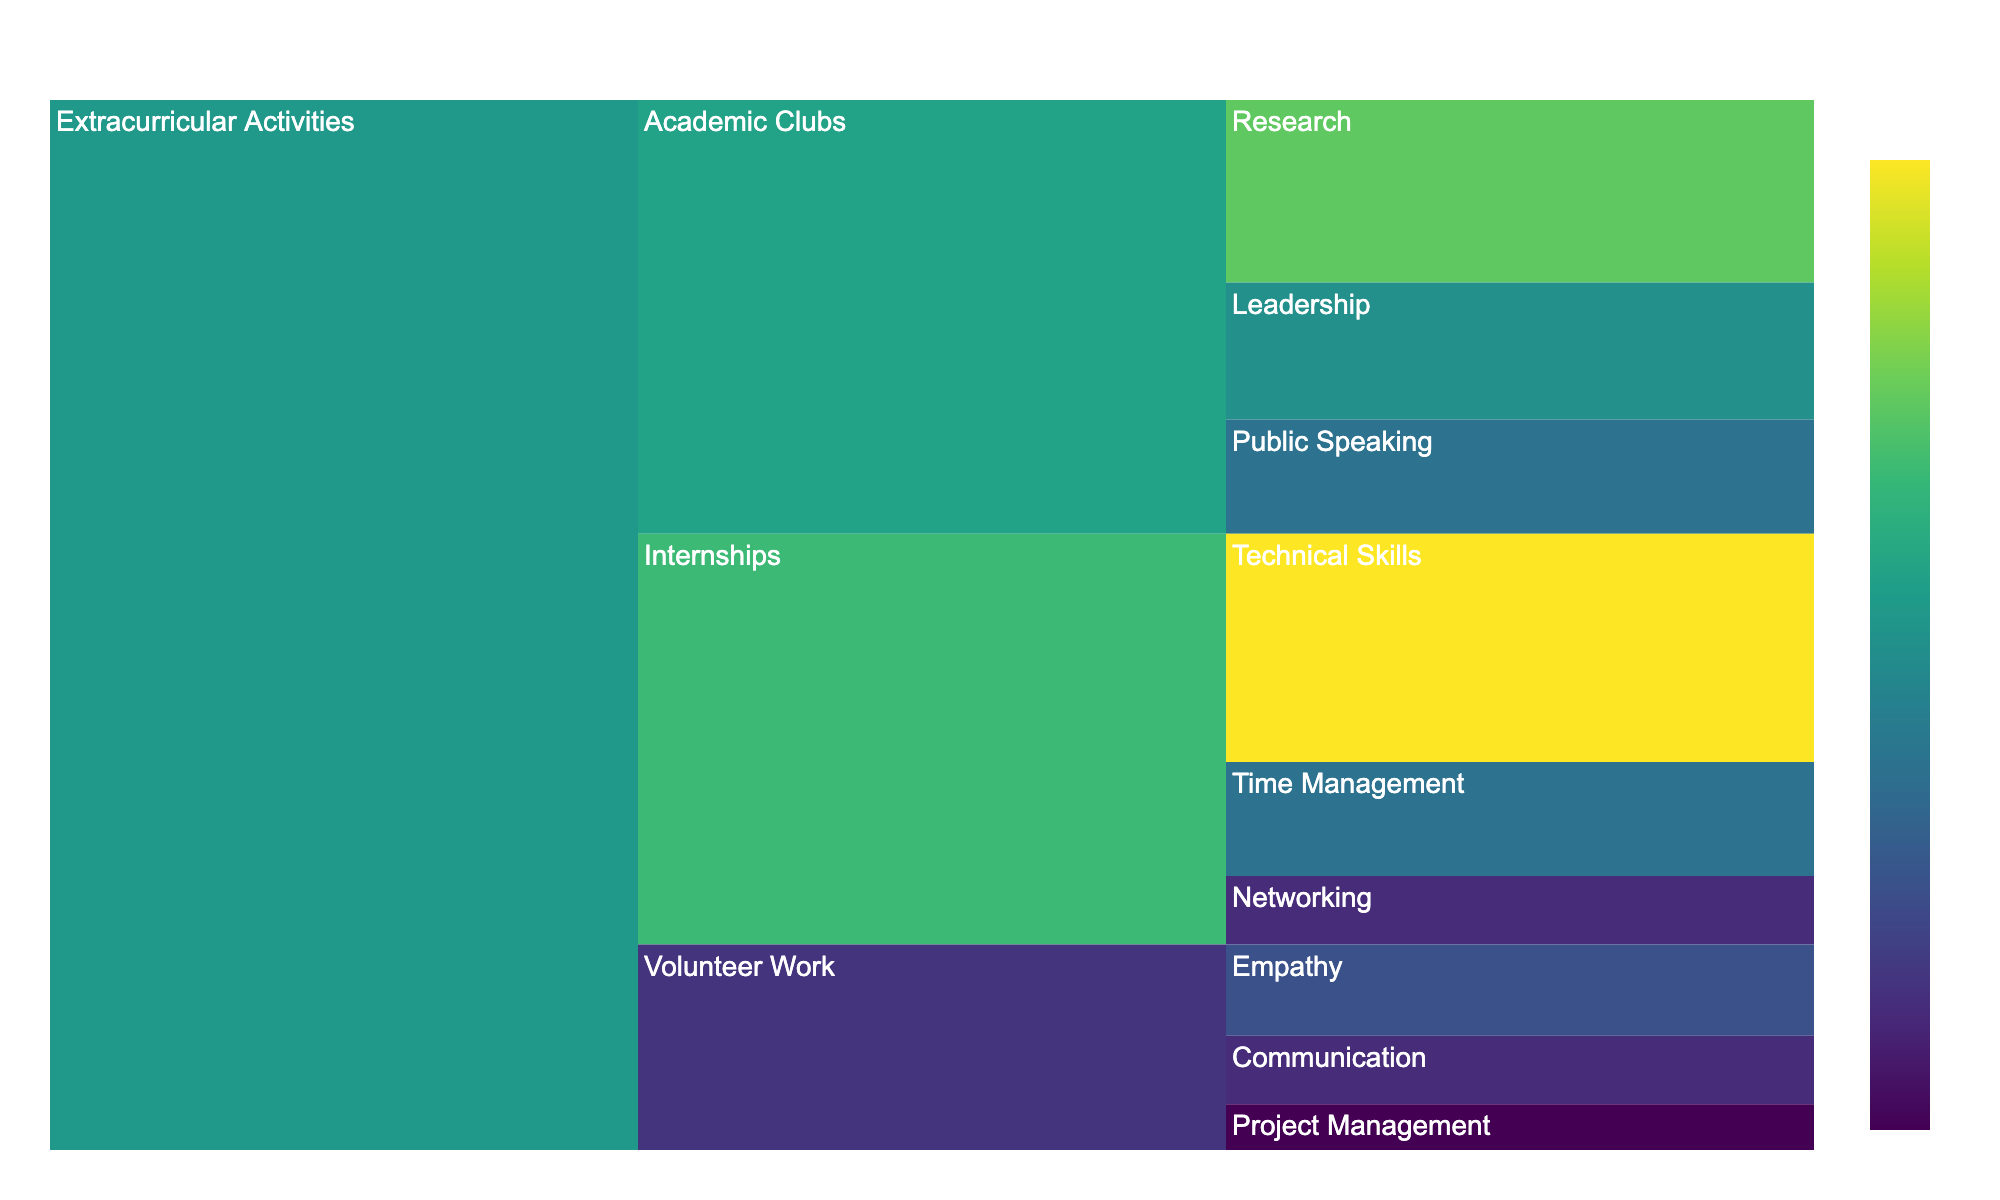What's the title of the figure? The title is located at the top of the figure and it summarizes the main topic of the chart. In this case, it reads "Time Management Analysis for Extracurricular Activities".
Answer: Time Management Analysis for Extracurricular Activities How many hours were spent on developing Leadership skills in Academic Clubs? Locate the section of the icicle chart labeled "Academic Clubs," find the subcategory "Leadership," and note the hours value. It shows 30 hours.
Answer: 30 Which category had the highest number of hours devoted to skill development? Compare the total number of hours for each of the main categories: Academic Clubs, Volunteer Work, and Internships. Add the hours for each category and find the one with the highest sum. Internships have the highest total with 90 hours.
Answer: Internships What is the total number of hours spent on Research within Academic Clubs? Find the subcategory "Academic Clubs," and look for "Research." The value for Research is 40 hours.
Answer: 40 How many more hours were spent on Technical Skills in Internships than on Empathy in Volunteer Work? Identify the hours for Technical Skills in Internships (50) and Empathy in Volunteer Work (20). Subtract the latter from the former: 50 - 20 = 30.
Answer: 30 What proportion of Volunteer Work hours was spent on Project Management? Calculate the total Volunteer Work hours by summing its subcategories (Empathy: 20, Communication: 15, Project Management: 10). Total hours = 20 + 15 + 10 = 45. Then, find the proportion for Project Management (10 / 45).
Answer: 10/45 or about 22.22% Which skill area in Internships used the least number of hours? Evaluate each skill area under Internships: Technical Skills (50), Networking (15), Time Management (25). Networking shows the least with 15 hours.
Answer: Networking How do the hours spent on Communication in Volunteer Work compare to those on Public Speaking in Academic Clubs? Locate the hours for Communication in Volunteer Work (15) and for Public Speaking in Academic Clubs (25). Communication has fewer hours than Public Speaking.
Answer: Fewer What's the total number of hours devoted to extracurricular activities? Sum up the hours from all skills: 30 + 25 + 40 + 20 + 15 + 10 + 50 + 15 + 25 = 220.
Answer: 220 